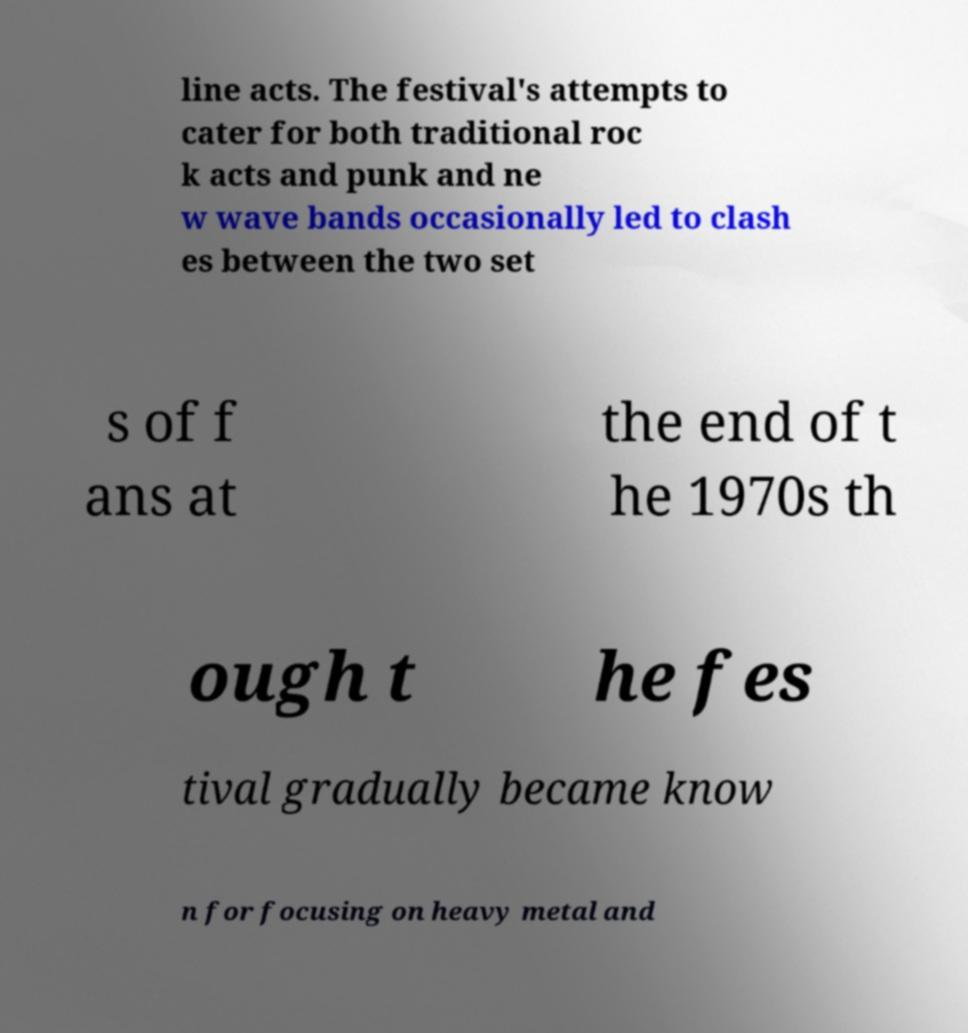For documentation purposes, I need the text within this image transcribed. Could you provide that? line acts. The festival's attempts to cater for both traditional roc k acts and punk and ne w wave bands occasionally led to clash es between the two set s of f ans at the end of t he 1970s th ough t he fes tival gradually became know n for focusing on heavy metal and 